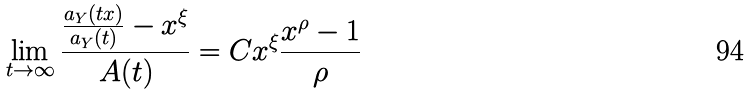<formula> <loc_0><loc_0><loc_500><loc_500>\lim _ { t \to \infty } \frac { \frac { a _ { Y } ( t x ) } { a _ { Y } ( t ) } - x ^ { \xi } } { A ( t ) } = C x ^ { \xi } \frac { x ^ { \rho } - 1 } { \rho }</formula> 